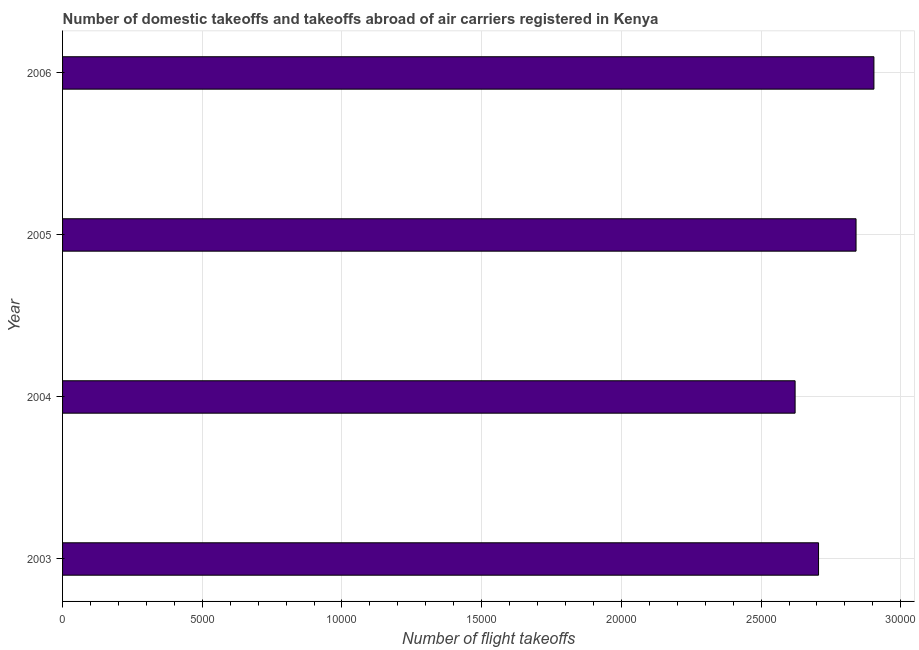Does the graph contain grids?
Your answer should be compact. Yes. What is the title of the graph?
Your response must be concise. Number of domestic takeoffs and takeoffs abroad of air carriers registered in Kenya. What is the label or title of the X-axis?
Your answer should be very brief. Number of flight takeoffs. What is the number of flight takeoffs in 2004?
Make the answer very short. 2.62e+04. Across all years, what is the maximum number of flight takeoffs?
Ensure brevity in your answer.  2.90e+04. Across all years, what is the minimum number of flight takeoffs?
Offer a terse response. 2.62e+04. In which year was the number of flight takeoffs maximum?
Ensure brevity in your answer.  2006. What is the sum of the number of flight takeoffs?
Offer a terse response. 1.11e+05. What is the difference between the number of flight takeoffs in 2004 and 2006?
Give a very brief answer. -2821. What is the average number of flight takeoffs per year?
Your answer should be very brief. 2.77e+04. What is the median number of flight takeoffs?
Offer a very short reply. 2.77e+04. In how many years, is the number of flight takeoffs greater than 17000 ?
Provide a succinct answer. 4. What is the ratio of the number of flight takeoffs in 2003 to that in 2004?
Your answer should be very brief. 1.03. Is the difference between the number of flight takeoffs in 2003 and 2005 greater than the difference between any two years?
Your response must be concise. No. What is the difference between the highest and the second highest number of flight takeoffs?
Provide a succinct answer. 640. What is the difference between the highest and the lowest number of flight takeoffs?
Keep it short and to the point. 2821. In how many years, is the number of flight takeoffs greater than the average number of flight takeoffs taken over all years?
Give a very brief answer. 2. What is the Number of flight takeoffs in 2003?
Provide a short and direct response. 2.71e+04. What is the Number of flight takeoffs in 2004?
Offer a very short reply. 2.62e+04. What is the Number of flight takeoffs in 2005?
Ensure brevity in your answer.  2.84e+04. What is the Number of flight takeoffs of 2006?
Provide a succinct answer. 2.90e+04. What is the difference between the Number of flight takeoffs in 2003 and 2004?
Make the answer very short. 839. What is the difference between the Number of flight takeoffs in 2003 and 2005?
Offer a very short reply. -1342. What is the difference between the Number of flight takeoffs in 2003 and 2006?
Your answer should be compact. -1982. What is the difference between the Number of flight takeoffs in 2004 and 2005?
Offer a very short reply. -2181. What is the difference between the Number of flight takeoffs in 2004 and 2006?
Provide a succinct answer. -2821. What is the difference between the Number of flight takeoffs in 2005 and 2006?
Your response must be concise. -640. What is the ratio of the Number of flight takeoffs in 2003 to that in 2004?
Make the answer very short. 1.03. What is the ratio of the Number of flight takeoffs in 2003 to that in 2005?
Offer a terse response. 0.95. What is the ratio of the Number of flight takeoffs in 2003 to that in 2006?
Keep it short and to the point. 0.93. What is the ratio of the Number of flight takeoffs in 2004 to that in 2005?
Make the answer very short. 0.92. What is the ratio of the Number of flight takeoffs in 2004 to that in 2006?
Provide a short and direct response. 0.9. What is the ratio of the Number of flight takeoffs in 2005 to that in 2006?
Keep it short and to the point. 0.98. 